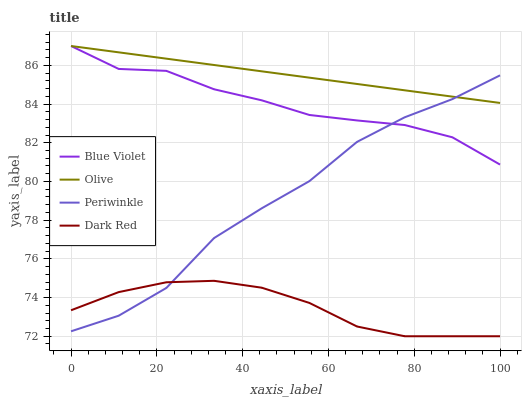Does Dark Red have the minimum area under the curve?
Answer yes or no. Yes. Does Olive have the maximum area under the curve?
Answer yes or no. Yes. Does Periwinkle have the minimum area under the curve?
Answer yes or no. No. Does Periwinkle have the maximum area under the curve?
Answer yes or no. No. Is Olive the smoothest?
Answer yes or no. Yes. Is Periwinkle the roughest?
Answer yes or no. Yes. Is Dark Red the smoothest?
Answer yes or no. No. Is Dark Red the roughest?
Answer yes or no. No. Does Periwinkle have the lowest value?
Answer yes or no. No. Does Periwinkle have the highest value?
Answer yes or no. No. Is Dark Red less than Olive?
Answer yes or no. Yes. Is Blue Violet greater than Dark Red?
Answer yes or no. Yes. Does Dark Red intersect Olive?
Answer yes or no. No. 